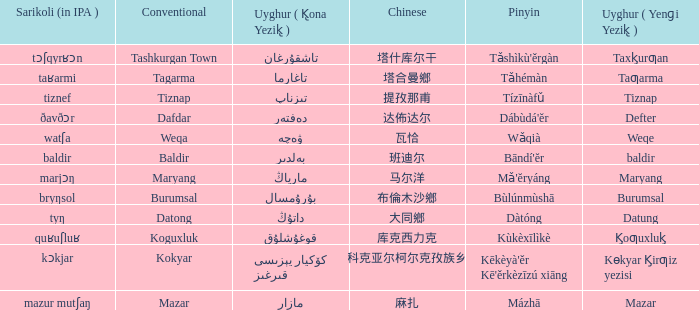Could you help me parse every detail presented in this table? {'header': ['Sarikoli (in IPA )', 'Conventional', 'Uyghur ( K̢ona Yezik̢ )', 'Chinese', 'Pinyin', 'Uyghur ( Yenɡi Yezik̢ )'], 'rows': [['tɔʃqyrʁɔn', 'Tashkurgan Town', 'تاشقۇرغان', '塔什库尔干', "Tǎshìkù'ěrgàn", 'Taxk̡urƣan'], ['taʁarmi', 'Tagarma', 'تاغارما', '塔合曼鄉', 'Tǎhémàn', 'Taƣarma'], ['tiznef', 'Tiznap', 'تىزناپ', '提孜那甫', 'Tízīnàfǔ', 'Tiznap'], ['ðavðɔr', 'Dafdar', 'دەفتەر', '达佈达尔', "Dábùdá'ĕr", 'Defter'], ['watʃa', 'Weqa', 'ۋەچە', '瓦恰', 'Wǎqià', 'Weqe'], ['baldir', 'Baldir', 'بەلدىر', '班迪尔', "Bāndí'ĕr", 'baldir'], ['marjɔŋ', 'Maryang', 'مارياڭ', '马尔洋', "Mǎ'ĕryáng", 'Maryang'], ['bryŋsol', 'Burumsal', 'بۇرۇمسال', '布倫木沙鄉', 'Bùlúnmùshā', 'Burumsal'], ['tyŋ', 'Datong', 'داتۇڭ', '大同鄉', 'Dàtóng', 'Datung'], ['quʁuʃluʁ', 'Koguxluk', 'قوغۇشلۇق', '库克西力克', 'Kùkèxīlìkè', 'K̡oƣuxluk̡'], ['kɔkjar', 'Kokyar', 'كۆكيار قىرغىز يېزىسى', '科克亚尔柯尔克孜族乡', "Kēkèyà'ěr Kē'ěrkèzīzú xiāng", 'Kɵkyar K̡irƣiz yezisi'], ['mazur mutʃaŋ', 'Mazar', 'مازار', '麻扎', 'Mázhā', 'Mazar']]} Name the pinyin for  kɵkyar k̡irƣiz yezisi Kēkèyà'ěr Kē'ěrkèzīzú xiāng. 